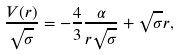<formula> <loc_0><loc_0><loc_500><loc_500>\frac { V ( r ) } { \sqrt { \sigma } } = - \frac { 4 } { 3 } \frac { \alpha } { r \sqrt { \sigma } } + \sqrt { \sigma } r ,</formula> 